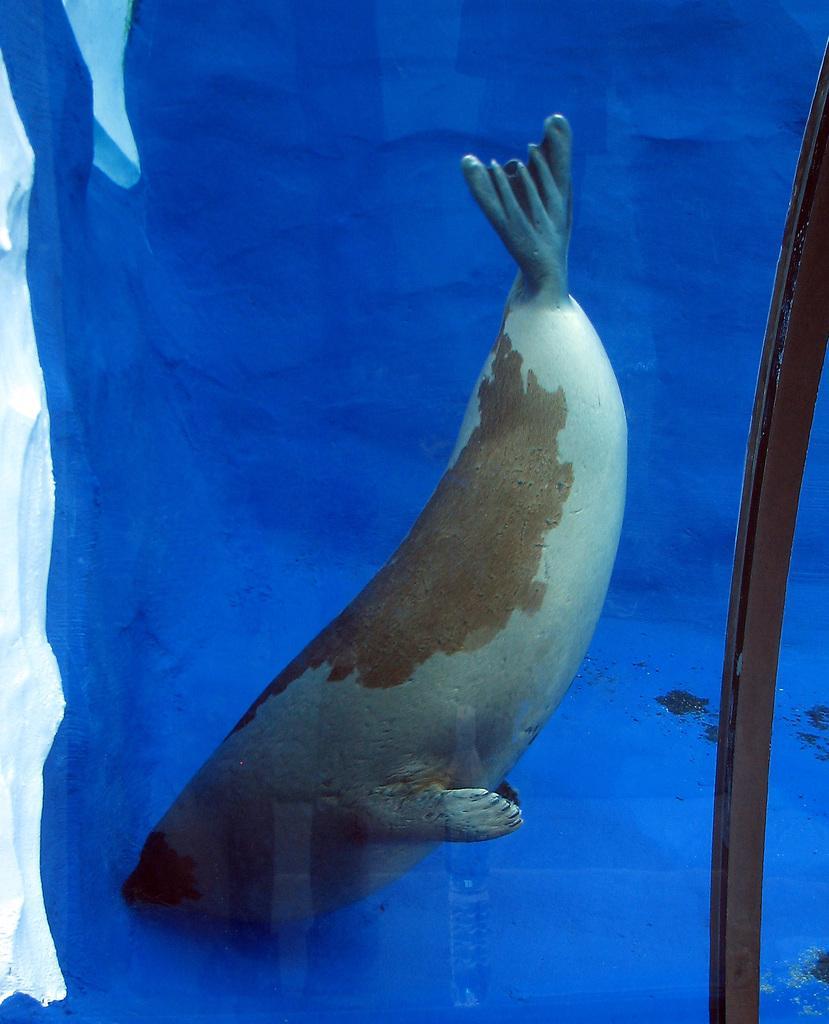Could you give a brief overview of what you see in this image? This is a painting. In the center of the image we can see a whale. In the background of the image we can see blue in color. 